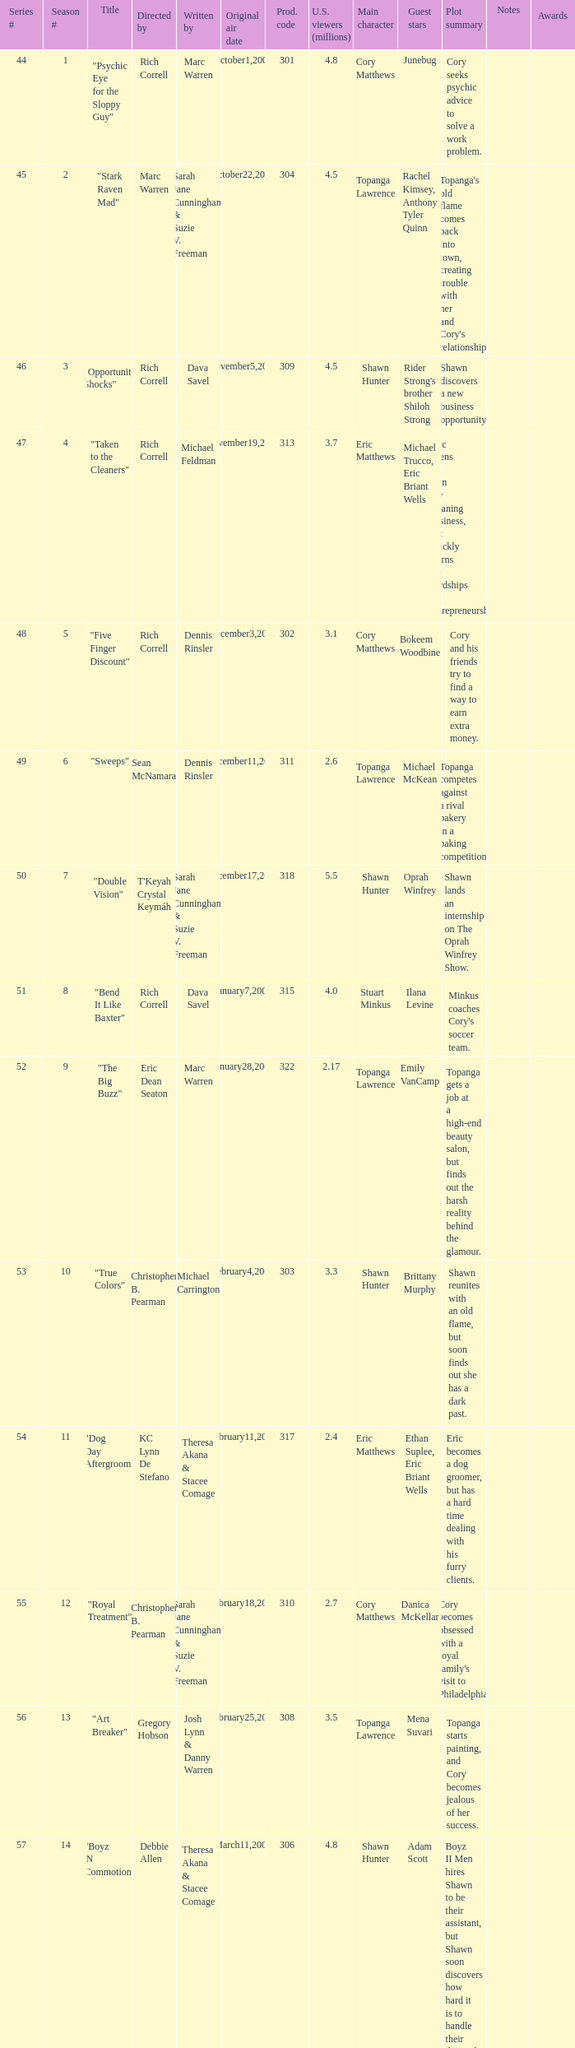What number episode of the season was titled "Vision Impossible"? 34.0. 